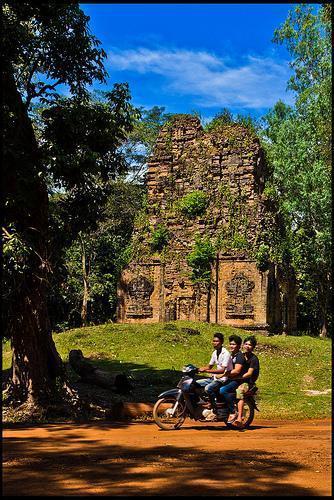How many kids are on the bike?
Give a very brief answer. 3. 